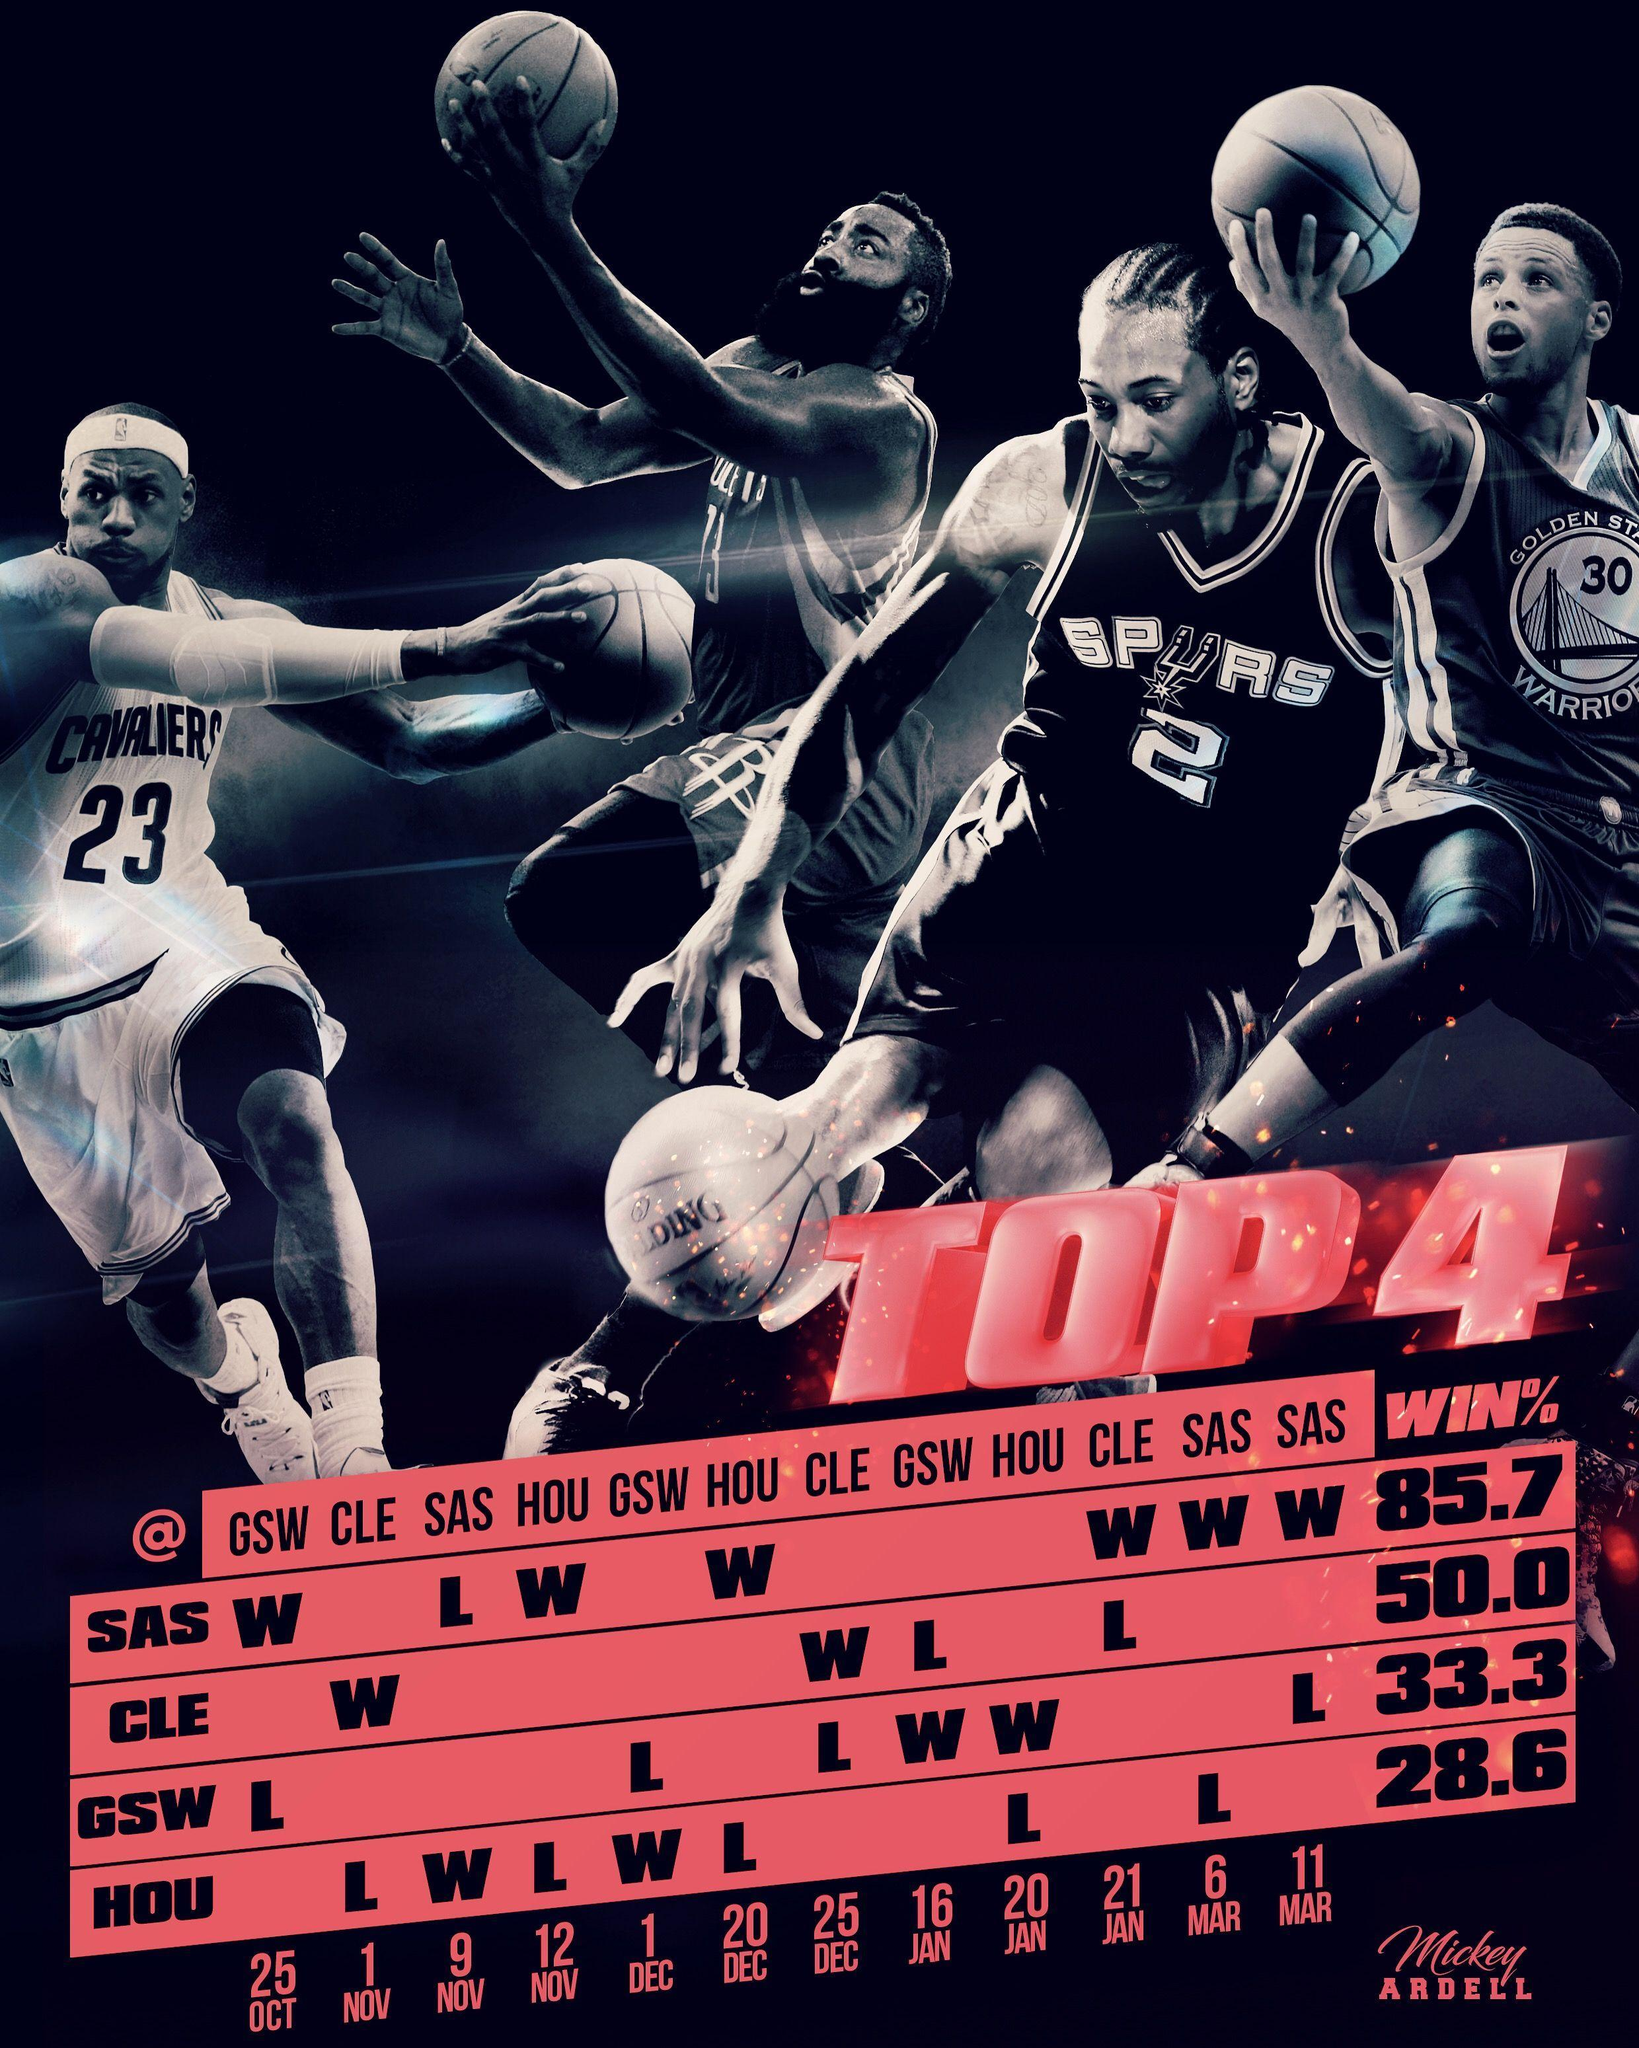Which team won the match played on 1st December?
Answer the question with a short phrase. HOU Against which team did SAS lose a match? HOU Which team won the match played on 20th January? GSW How many matches were won by the team CLE? 2 In how many matches did the team HOU lose? 5 How many matches did the team SAS win? 6 Which team won the match played on 1st November? CLE How many matches did the team GSW win? 2 On which date did SAS lose in a match? 9 Nov How many matches were played by the team CLE? 4 